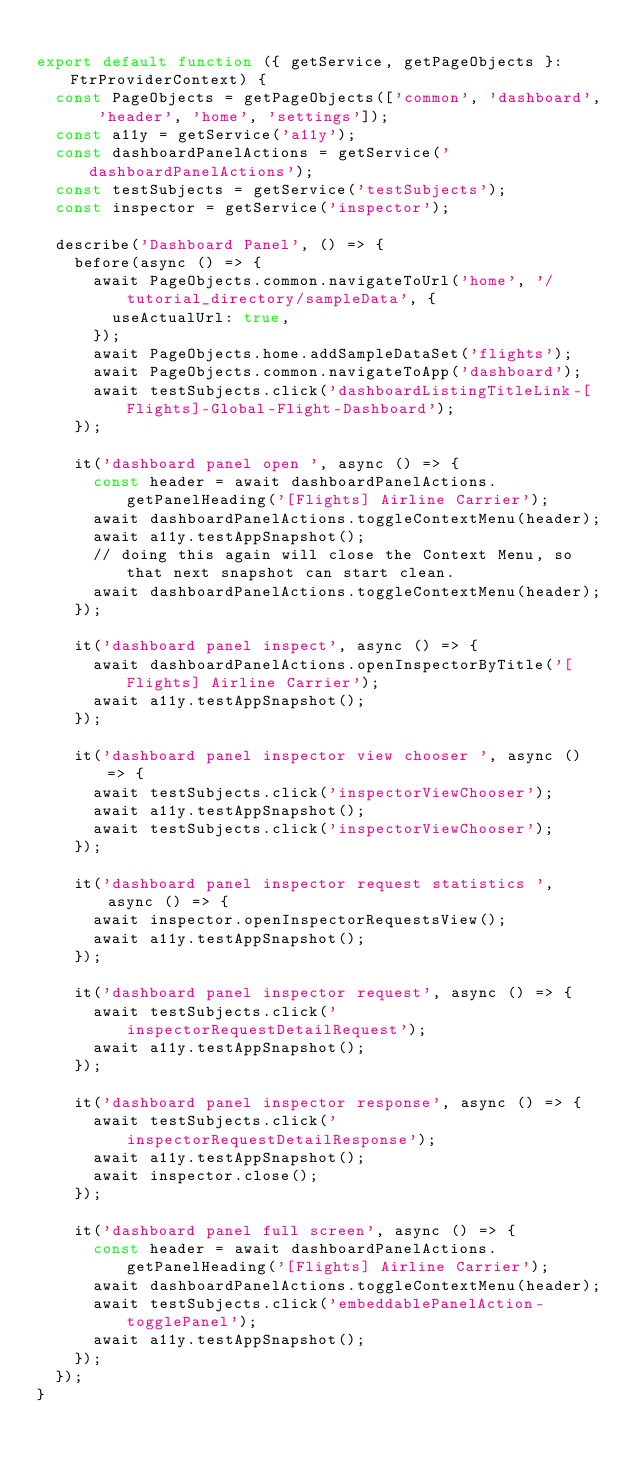Convert code to text. <code><loc_0><loc_0><loc_500><loc_500><_TypeScript_>
export default function ({ getService, getPageObjects }: FtrProviderContext) {
  const PageObjects = getPageObjects(['common', 'dashboard', 'header', 'home', 'settings']);
  const a11y = getService('a11y');
  const dashboardPanelActions = getService('dashboardPanelActions');
  const testSubjects = getService('testSubjects');
  const inspector = getService('inspector');

  describe('Dashboard Panel', () => {
    before(async () => {
      await PageObjects.common.navigateToUrl('home', '/tutorial_directory/sampleData', {
        useActualUrl: true,
      });
      await PageObjects.home.addSampleDataSet('flights');
      await PageObjects.common.navigateToApp('dashboard');
      await testSubjects.click('dashboardListingTitleLink-[Flights]-Global-Flight-Dashboard');
    });

    it('dashboard panel open ', async () => {
      const header = await dashboardPanelActions.getPanelHeading('[Flights] Airline Carrier');
      await dashboardPanelActions.toggleContextMenu(header);
      await a11y.testAppSnapshot();
      // doing this again will close the Context Menu, so that next snapshot can start clean.
      await dashboardPanelActions.toggleContextMenu(header);
    });

    it('dashboard panel inspect', async () => {
      await dashboardPanelActions.openInspectorByTitle('[Flights] Airline Carrier');
      await a11y.testAppSnapshot();
    });

    it('dashboard panel inspector view chooser ', async () => {
      await testSubjects.click('inspectorViewChooser');
      await a11y.testAppSnapshot();
      await testSubjects.click('inspectorViewChooser');
    });

    it('dashboard panel inspector request statistics ', async () => {
      await inspector.openInspectorRequestsView();
      await a11y.testAppSnapshot();
    });

    it('dashboard panel inspector request', async () => {
      await testSubjects.click('inspectorRequestDetailRequest');
      await a11y.testAppSnapshot();
    });

    it('dashboard panel inspector response', async () => {
      await testSubjects.click('inspectorRequestDetailResponse');
      await a11y.testAppSnapshot();
      await inspector.close();
    });

    it('dashboard panel full screen', async () => {
      const header = await dashboardPanelActions.getPanelHeading('[Flights] Airline Carrier');
      await dashboardPanelActions.toggleContextMenu(header);
      await testSubjects.click('embeddablePanelAction-togglePanel');
      await a11y.testAppSnapshot();
    });
  });
}
</code> 